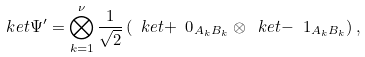<formula> <loc_0><loc_0><loc_500><loc_500>\ k e t { \Psi ^ { \prime } } = \bigotimes _ { k = 1 } ^ { \nu } \frac { 1 } { \sqrt { 2 } } \left ( \ k e t { + \ 0 } _ { A _ { k } B _ { k } } \otimes \ k e t { - \ 1 } _ { A _ { k } B _ { k } } \right ) ,</formula> 